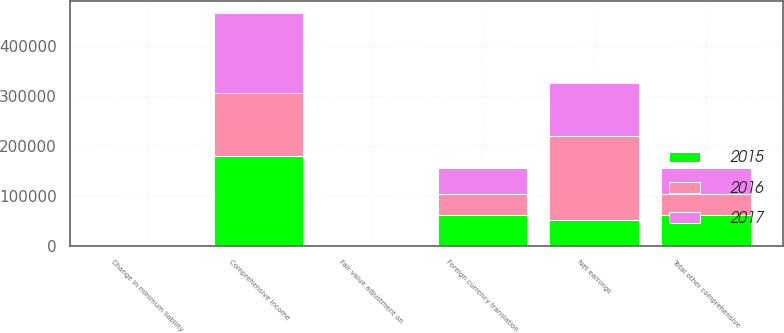Convert chart. <chart><loc_0><loc_0><loc_500><loc_500><stacked_bar_chart><ecel><fcel>Net earnings<fcel>Change in minimum liability<fcel>Fair value adjustment on<fcel>Foreign currency translation<fcel>Total other comprehensive<fcel>Comprehensive income<nl><fcel>2017<fcel>107223<fcel>1271<fcel>187<fcel>51631<fcel>52591<fcel>159814<nl><fcel>2016<fcel>166626<fcel>102<fcel>16<fcel>40911<fcel>40825<fcel>125801<nl><fcel>2015<fcel>51631<fcel>661<fcel>602<fcel>61776<fcel>61717<fcel>179969<nl></chart> 